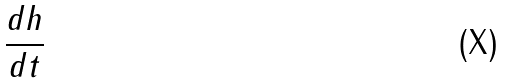Convert formula to latex. <formula><loc_0><loc_0><loc_500><loc_500>\frac { d h } { d t }</formula> 